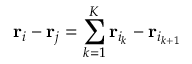<formula> <loc_0><loc_0><loc_500><loc_500>{ r } _ { i } - { r } _ { j } = \sum _ { k = 1 } ^ { K } { r } _ { i _ { k } } - { r } _ { i _ { k + 1 } }</formula> 